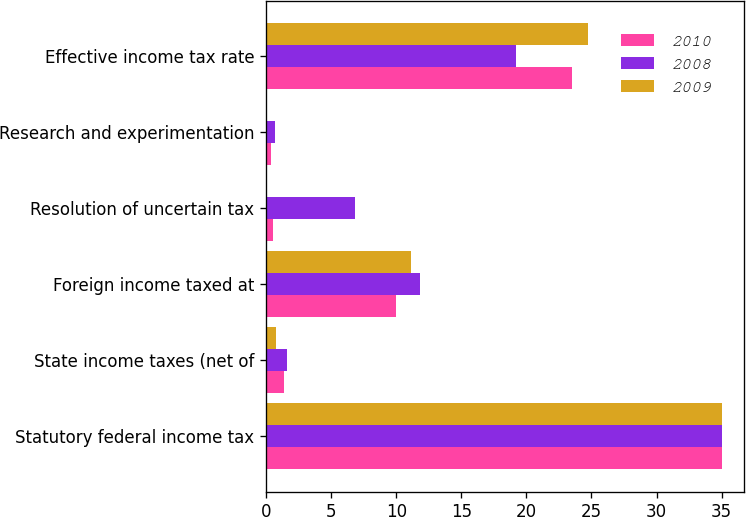<chart> <loc_0><loc_0><loc_500><loc_500><stacked_bar_chart><ecel><fcel>Statutory federal income tax<fcel>State income taxes (net of<fcel>Foreign income taxed at<fcel>Resolution of uncertain tax<fcel>Research and experimentation<fcel>Effective income tax rate<nl><fcel>2010<fcel>35<fcel>1.4<fcel>10<fcel>0.5<fcel>0.4<fcel>23.5<nl><fcel>2008<fcel>35<fcel>1.6<fcel>11.8<fcel>6.8<fcel>0.7<fcel>19.2<nl><fcel>2009<fcel>35<fcel>0.8<fcel>11.1<fcel>0.1<fcel>0.1<fcel>24.7<nl></chart> 